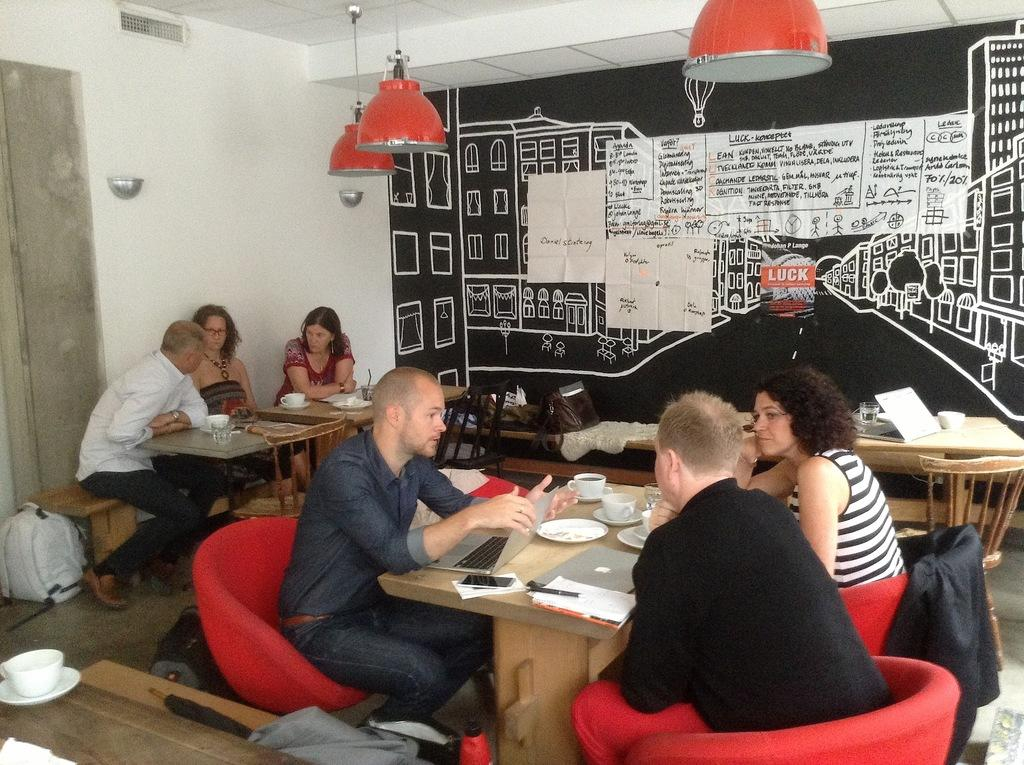What are the people in the image doing? The people in the image are sitting on chairs. What can be seen on the tables in the image? There are objects on the tables in the image. What is visible in the background of the image? There is a wall, papers, and lights in the background of the image. How much dirt can be seen on the floor in the image? There is no dirt visible on the floor in the image. What type of sky is visible in the image? The image does not show any sky; it is set indoors. 